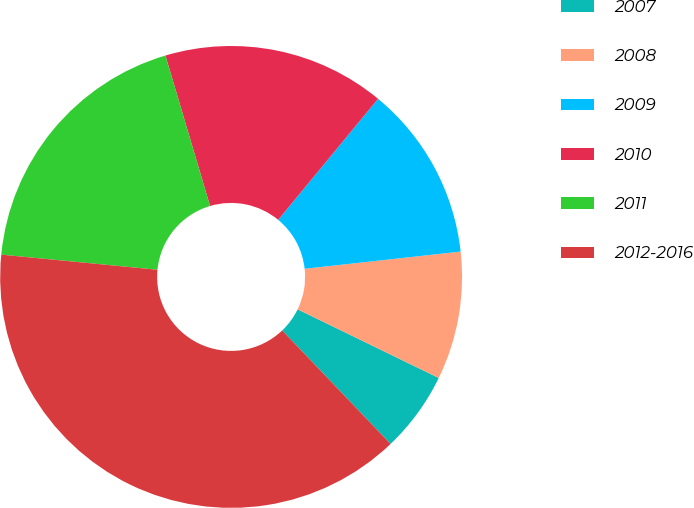Convert chart. <chart><loc_0><loc_0><loc_500><loc_500><pie_chart><fcel>2007<fcel>2008<fcel>2009<fcel>2010<fcel>2011<fcel>2012-2016<nl><fcel>5.66%<fcel>8.96%<fcel>12.27%<fcel>15.57%<fcel>18.87%<fcel>38.67%<nl></chart> 